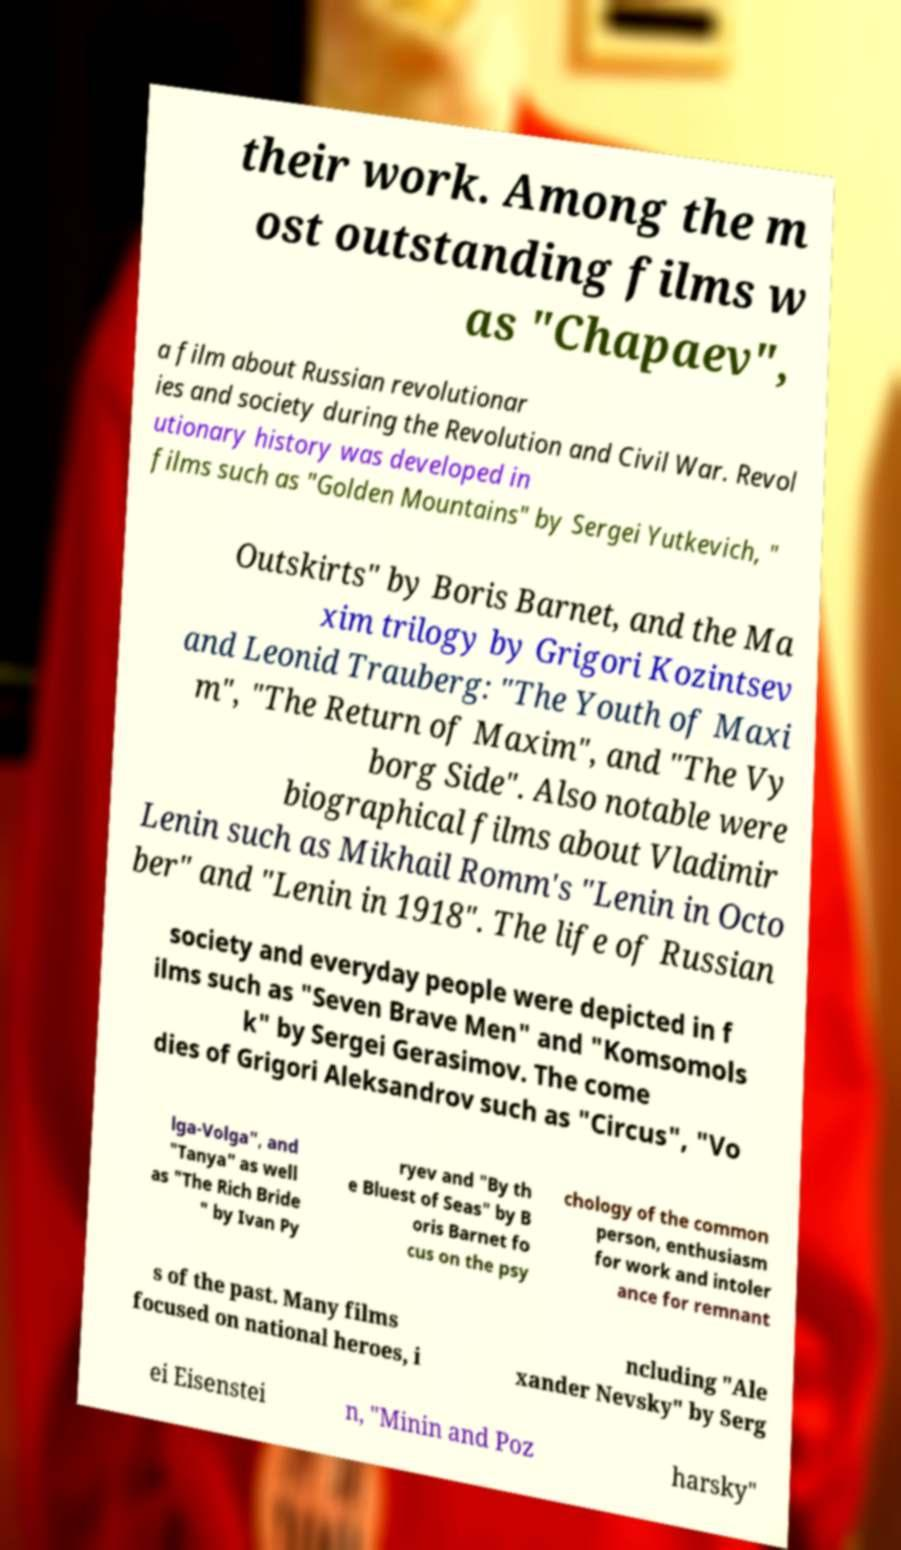Could you extract and type out the text from this image? their work. Among the m ost outstanding films w as "Chapaev", a film about Russian revolutionar ies and society during the Revolution and Civil War. Revol utionary history was developed in films such as "Golden Mountains" by Sergei Yutkevich, " Outskirts" by Boris Barnet, and the Ma xim trilogy by Grigori Kozintsev and Leonid Trauberg: "The Youth of Maxi m", "The Return of Maxim", and "The Vy borg Side". Also notable were biographical films about Vladimir Lenin such as Mikhail Romm's "Lenin in Octo ber" and "Lenin in 1918". The life of Russian society and everyday people were depicted in f ilms such as "Seven Brave Men" and "Komsomols k" by Sergei Gerasimov. The come dies of Grigori Aleksandrov such as "Circus", "Vo lga-Volga", and "Tanya" as well as "The Rich Bride " by Ivan Py ryev and "By th e Bluest of Seas" by B oris Barnet fo cus on the psy chology of the common person, enthusiasm for work and intoler ance for remnant s of the past. Many films focused on national heroes, i ncluding "Ale xander Nevsky" by Serg ei Eisenstei n, "Minin and Poz harsky" 